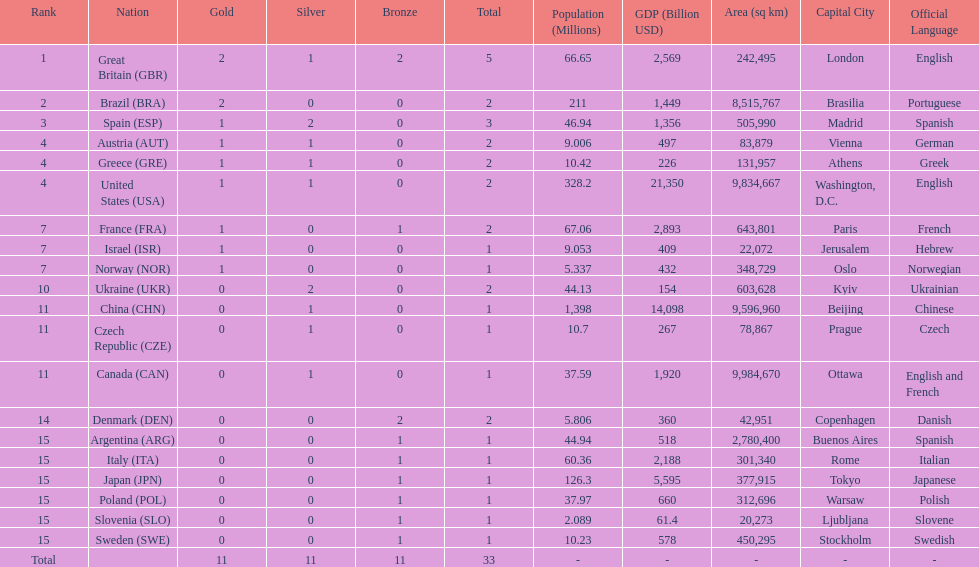How many countries won at least 2 medals in sailing? 9. 